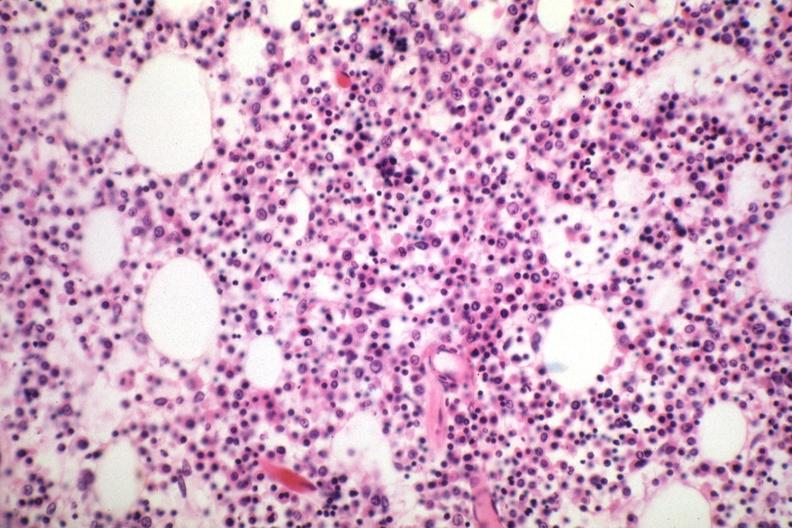what loaded with plasma cells that are immature?
Answer the question using a single word or phrase. Marrow 